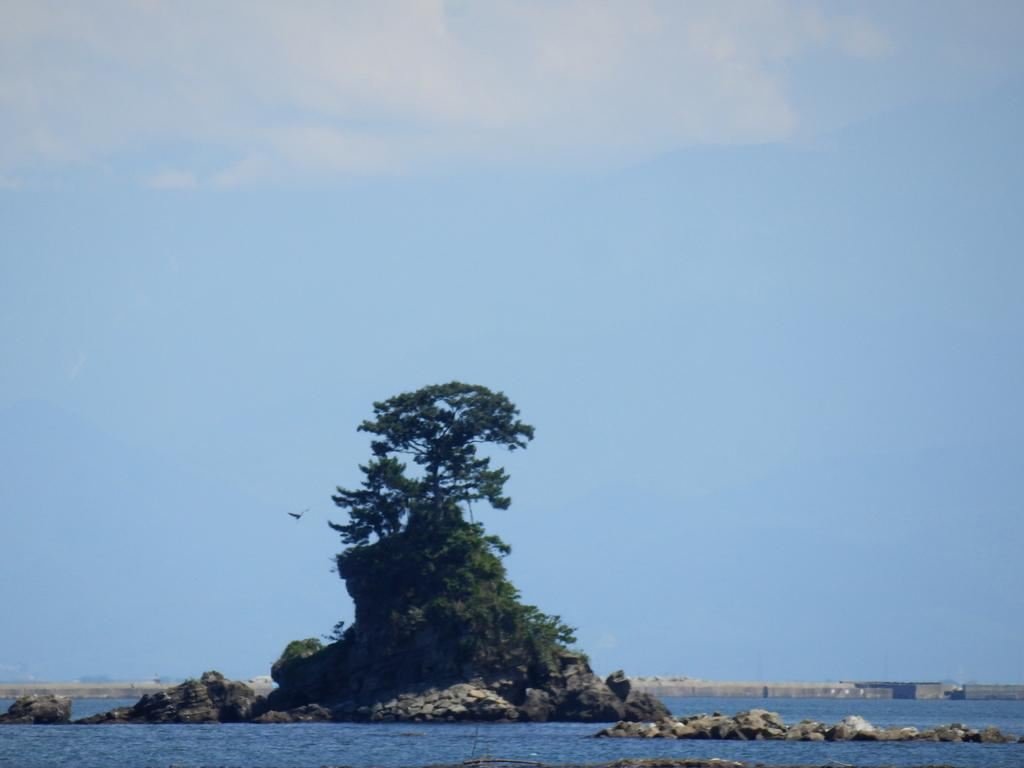What is visible in the image that is not solid? Water is visible in the image and is not solid. What part of the natural environment is visible in the image? The sky and trees are visible in the image. What statement does the stranger make in the image? There is no stranger present in the image, so no statement can be attributed to them. What type of cup is being used in the image? There is no cup visible in the image. 